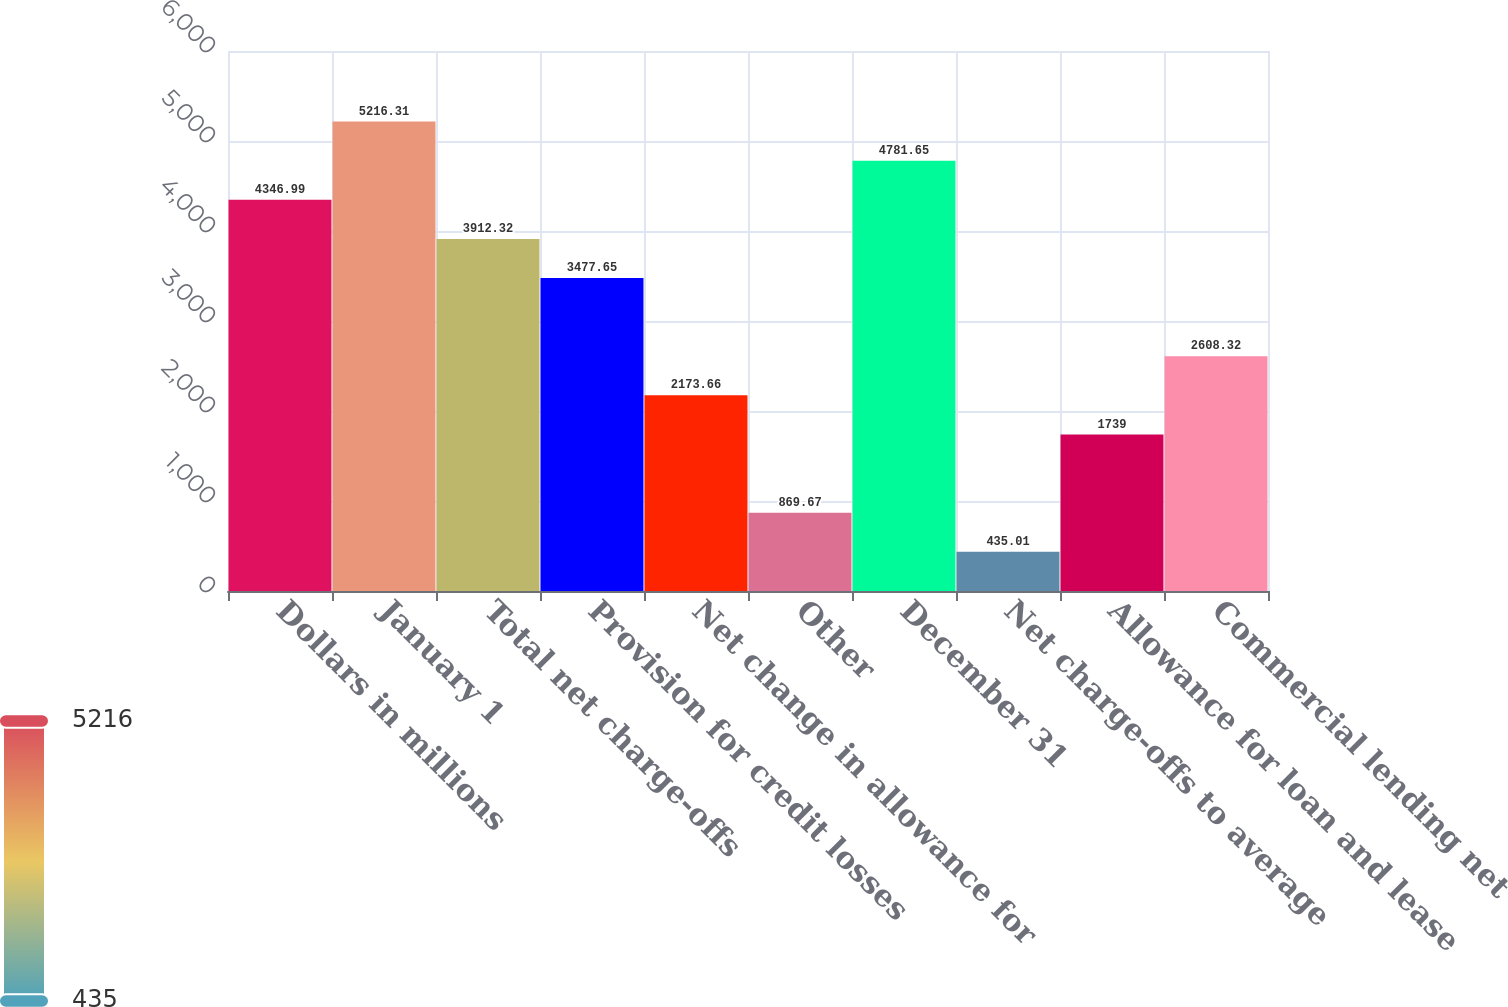Convert chart to OTSL. <chart><loc_0><loc_0><loc_500><loc_500><bar_chart><fcel>Dollars in millions<fcel>January 1<fcel>Total net charge-offs<fcel>Provision for credit losses<fcel>Net change in allowance for<fcel>Other<fcel>December 31<fcel>Net charge-offs to average<fcel>Allowance for loan and lease<fcel>Commercial lending net<nl><fcel>4346.99<fcel>5216.31<fcel>3912.32<fcel>3477.65<fcel>2173.66<fcel>869.67<fcel>4781.65<fcel>435.01<fcel>1739<fcel>2608.32<nl></chart> 